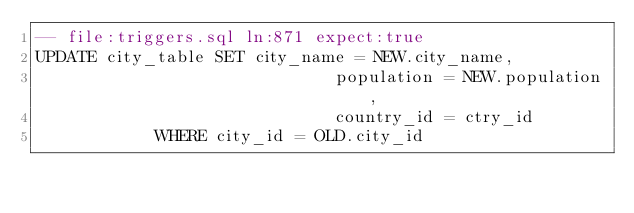<code> <loc_0><loc_0><loc_500><loc_500><_SQL_>-- file:triggers.sql ln:871 expect:true
UPDATE city_table SET city_name = NEW.city_name,
                              population = NEW.population,
                              country_id = ctry_id
            WHERE city_id = OLD.city_id
</code> 